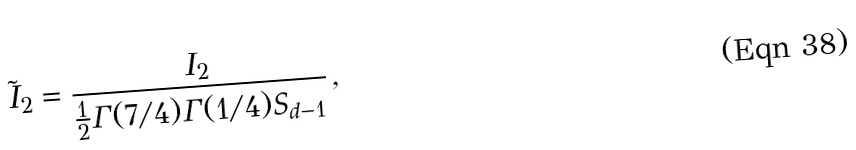Convert formula to latex. <formula><loc_0><loc_0><loc_500><loc_500>\tilde { I } _ { 2 } = \frac { I _ { 2 } } { \frac { 1 } { 2 } \Gamma ( 7 / 4 ) \Gamma ( 1 / 4 ) S _ { d - 1 } } \, ,</formula> 